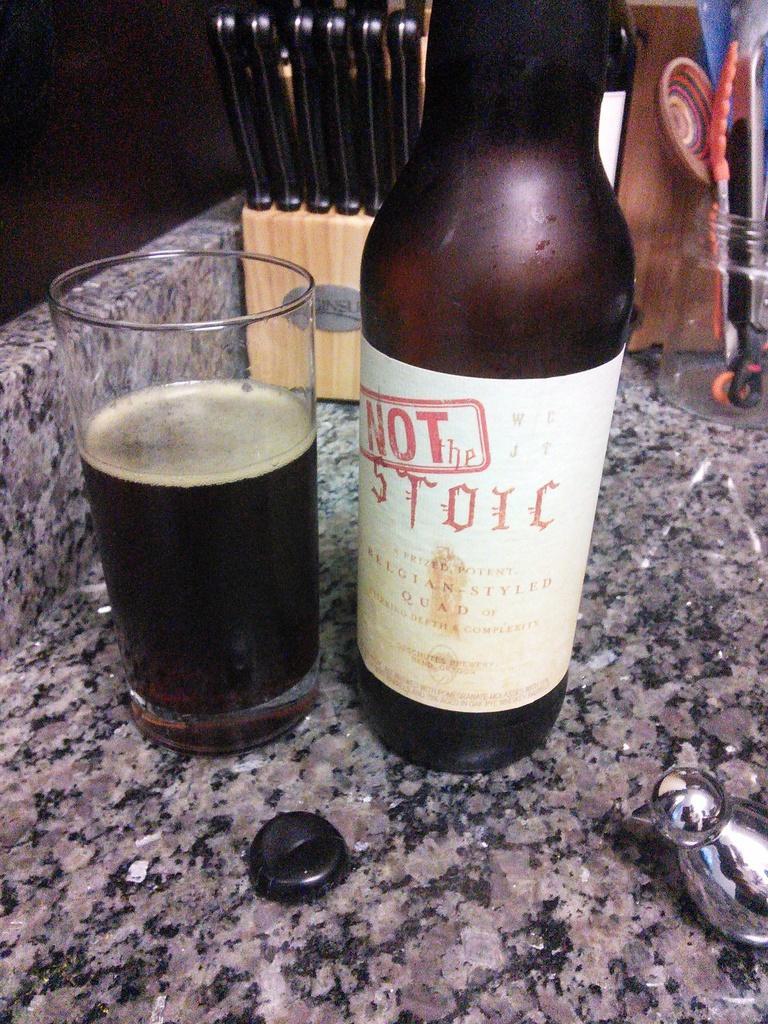Describe this image in one or two sentences. In this image we can see a bottle. We can see some drink in the glass. There are few utensils in the image. There are few objects in the image. 